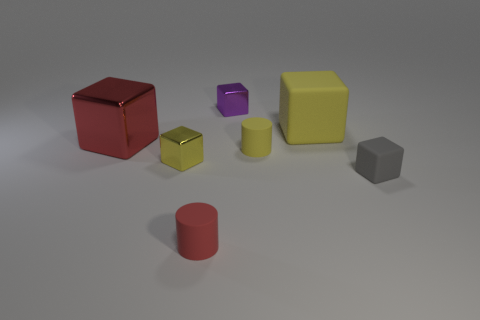Add 1 large red metallic objects. How many objects exist? 8 Subtract all cylinders. How many objects are left? 5 Subtract all small matte cubes. Subtract all big yellow objects. How many objects are left? 5 Add 5 purple objects. How many purple objects are left? 6 Add 1 large yellow matte spheres. How many large yellow matte spheres exist? 1 Subtract 0 gray cylinders. How many objects are left? 7 